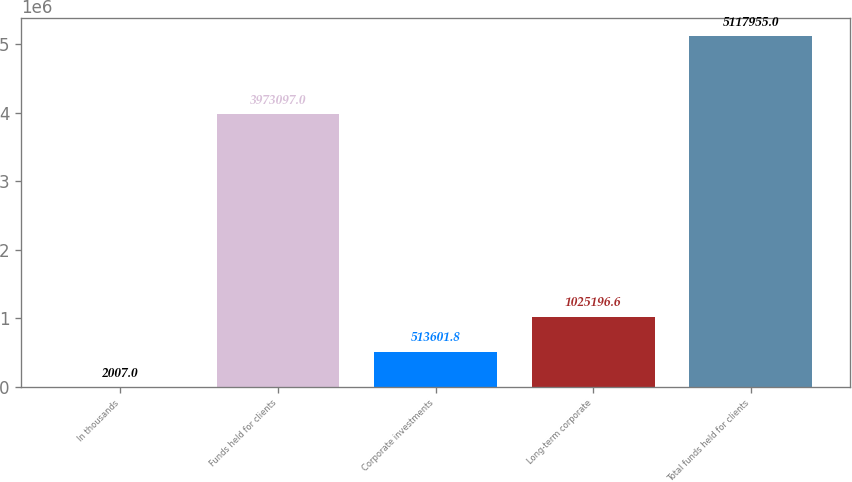<chart> <loc_0><loc_0><loc_500><loc_500><bar_chart><fcel>In thousands<fcel>Funds held for clients<fcel>Corporate investments<fcel>Long-term corporate<fcel>Total funds held for clients<nl><fcel>2007<fcel>3.9731e+06<fcel>513602<fcel>1.0252e+06<fcel>5.11796e+06<nl></chart> 